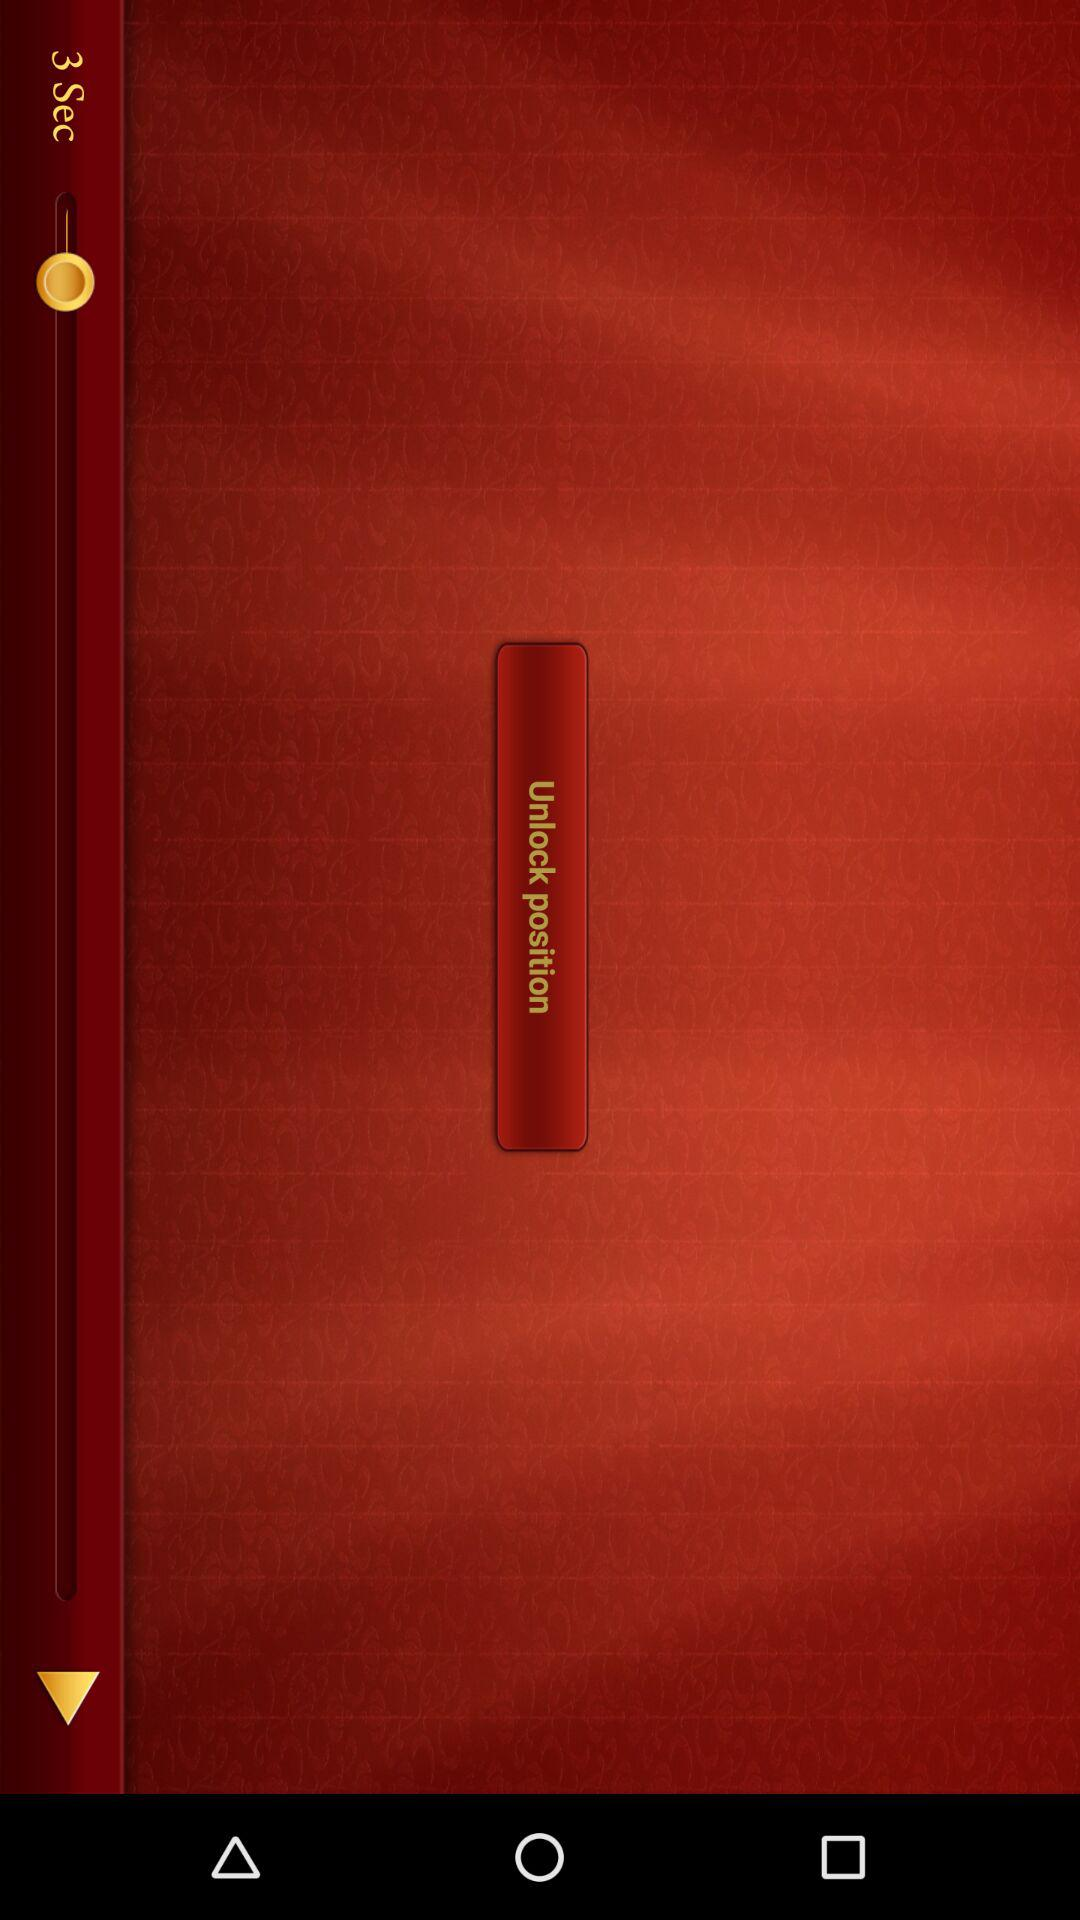What is the percentage of "Quick" category in Ideas? The percentage is 0. 